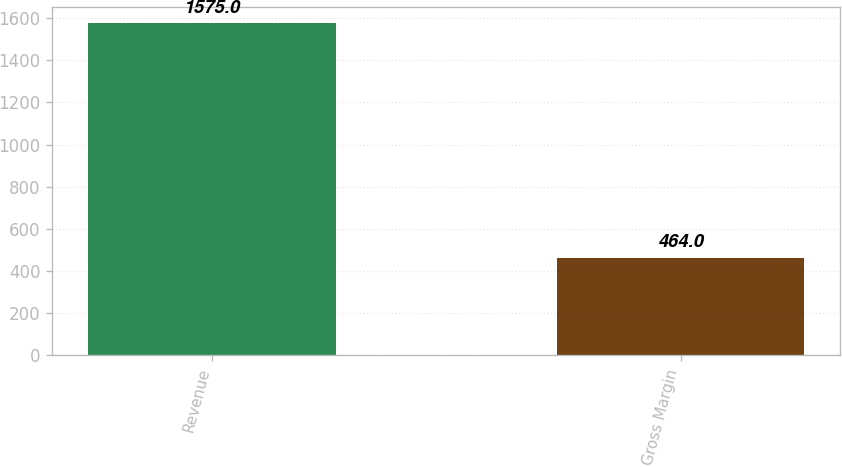Convert chart. <chart><loc_0><loc_0><loc_500><loc_500><bar_chart><fcel>Revenue<fcel>Gross Margin<nl><fcel>1575<fcel>464<nl></chart> 